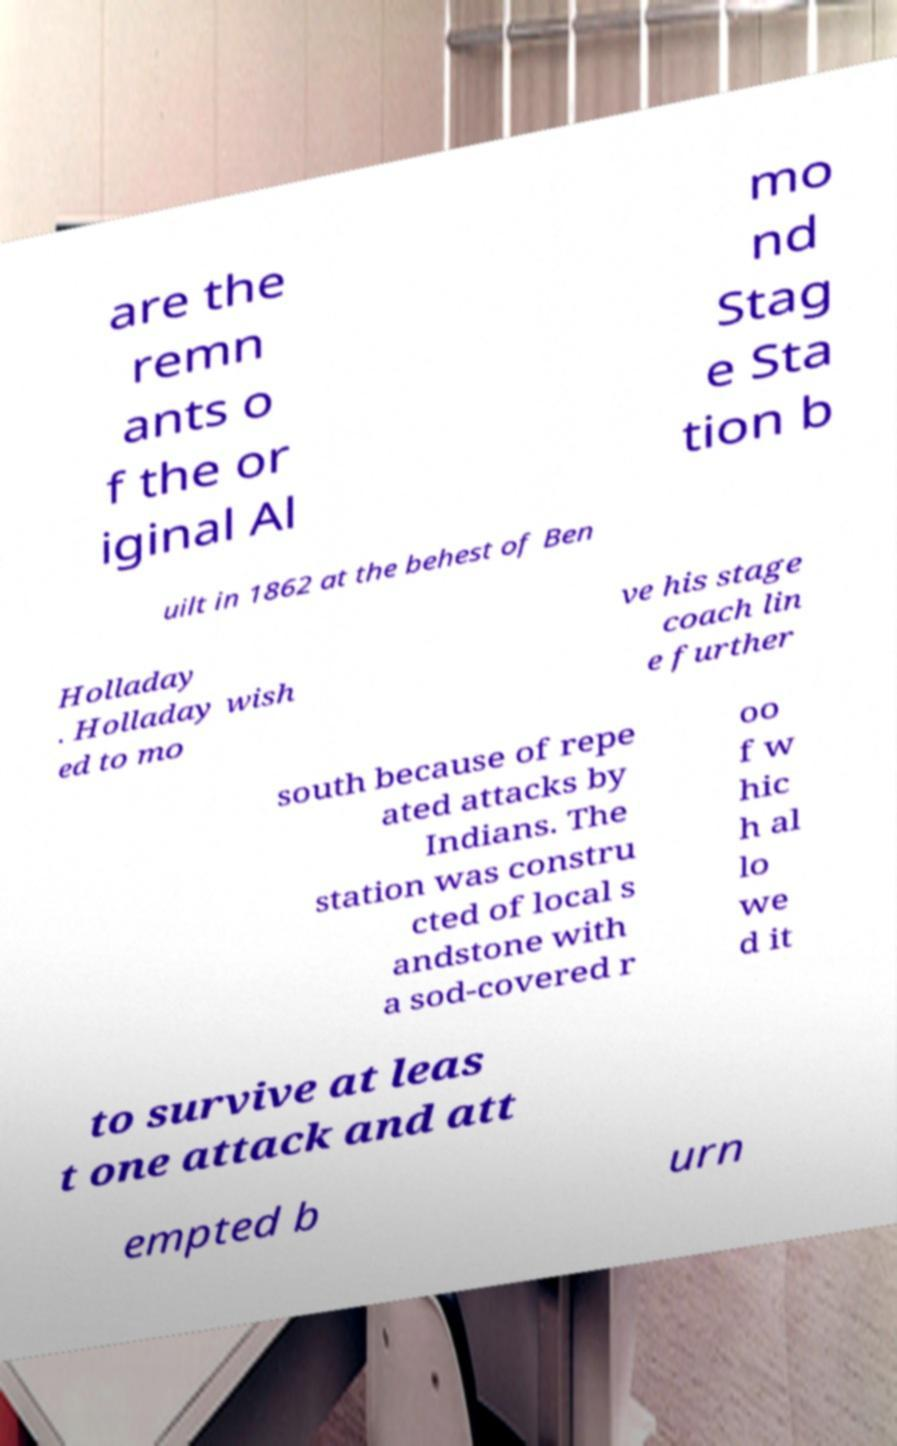Could you assist in decoding the text presented in this image and type it out clearly? are the remn ants o f the or iginal Al mo nd Stag e Sta tion b uilt in 1862 at the behest of Ben Holladay . Holladay wish ed to mo ve his stage coach lin e further south because of repe ated attacks by Indians. The station was constru cted of local s andstone with a sod-covered r oo f w hic h al lo we d it to survive at leas t one attack and att empted b urn 